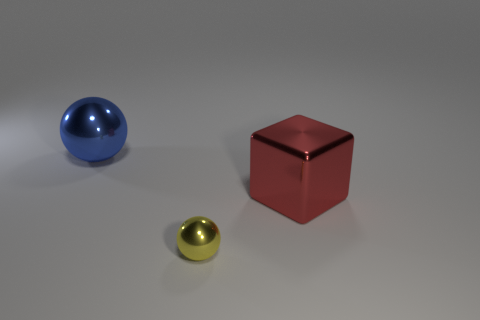Add 1 small spheres. How many objects exist? 4 Subtract all cubes. How many objects are left? 2 Add 2 blue metal objects. How many blue metal objects are left? 3 Add 2 yellow metallic things. How many yellow metallic things exist? 3 Subtract 0 cyan cylinders. How many objects are left? 3 Subtract all tiny purple matte things. Subtract all large blue shiny balls. How many objects are left? 2 